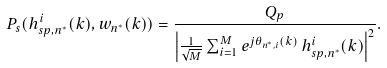Convert formula to latex. <formula><loc_0><loc_0><loc_500><loc_500>P _ { s } ( { h ^ { i } _ { s p , n ^ { * } } } ( k ) , { w _ { n ^ { * } } } ( k ) ) = \frac { Q _ { p } } { \left | \frac { 1 } { \sqrt { M } } \sum _ { i = 1 } ^ { M } e ^ { j \theta _ { n ^ { * } , i } ( k ) } \, h ^ { i } _ { s p , n ^ { * } } ( k ) \right | ^ { 2 } } .</formula> 